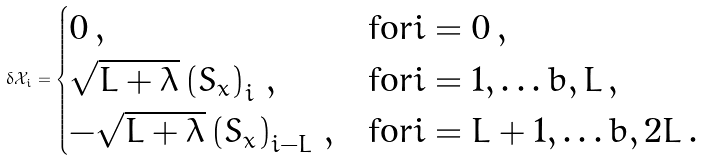Convert formula to latex. <formula><loc_0><loc_0><loc_500><loc_500>\delta \mathcal { X } _ { i } = \begin{cases} 0 \, , & \text {for} i = 0 \, , \\ \sqrt { L + \lambda } \left ( S _ { x } \right ) _ { i } \, , & \text {for} i = 1 , \dots b , L \, , \\ - \sqrt { L + \lambda } \left ( S _ { x } \right ) _ { i - L } \, , & \text {for} i = L + 1 , \dots b , 2 L \, . \\ \end{cases}</formula> 